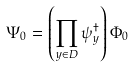<formula> <loc_0><loc_0><loc_500><loc_500>\Psi _ { 0 } = \left ( \prod _ { y \in D } \psi _ { y } ^ { \dagger } \right ) \Phi _ { 0 }</formula> 